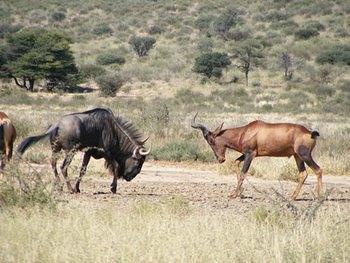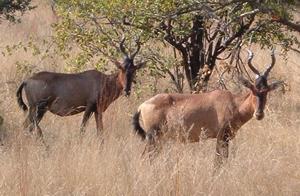The first image is the image on the left, the second image is the image on the right. For the images displayed, is the sentence "In one of the images, there is an animal near water." factually correct? Answer yes or no. No. The first image is the image on the left, the second image is the image on the right. For the images shown, is this caption "There are exactly two horned animals standing in total." true? Answer yes or no. No. 